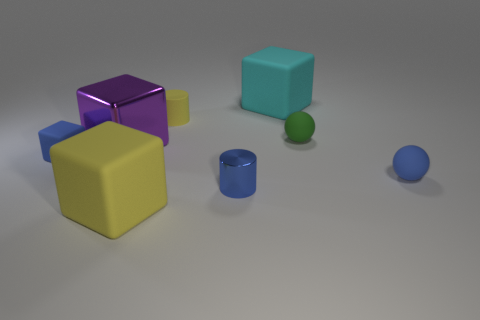Subtract all rubber cubes. How many cubes are left? 1 Add 1 blue metallic cylinders. How many objects exist? 9 Subtract all blue cylinders. How many cylinders are left? 1 Subtract 2 spheres. How many spheres are left? 0 Subtract all balls. How many objects are left? 6 Subtract all red cylinders. How many cyan blocks are left? 1 Subtract all brown rubber balls. Subtract all green spheres. How many objects are left? 7 Add 4 balls. How many balls are left? 6 Add 8 cylinders. How many cylinders exist? 10 Subtract 1 blue cylinders. How many objects are left? 7 